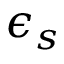<formula> <loc_0><loc_0><loc_500><loc_500>\epsilon _ { s }</formula> 